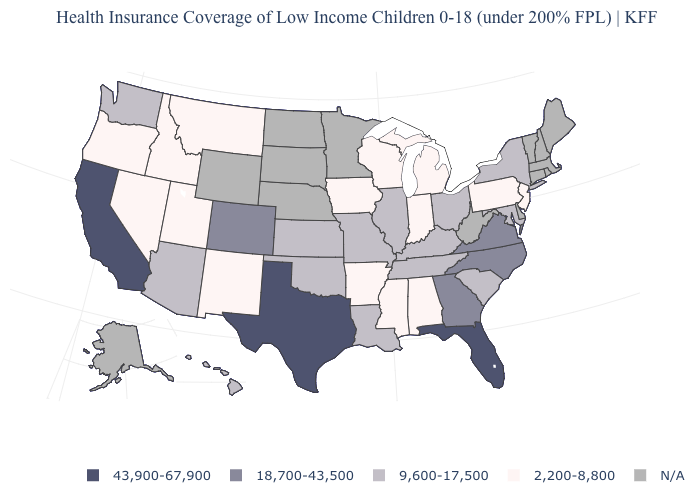Among the states that border New Jersey , which have the highest value?
Write a very short answer. New York. Does the first symbol in the legend represent the smallest category?
Keep it brief. No. How many symbols are there in the legend?
Give a very brief answer. 5. Name the states that have a value in the range 2,200-8,800?
Write a very short answer. Alabama, Arkansas, Idaho, Indiana, Iowa, Michigan, Mississippi, Montana, Nevada, New Jersey, New Mexico, Oregon, Pennsylvania, Utah, Wisconsin. Name the states that have a value in the range 9,600-17,500?
Quick response, please. Arizona, Hawaii, Illinois, Kansas, Kentucky, Louisiana, Maryland, Missouri, New York, Ohio, Oklahoma, South Carolina, Tennessee, Washington. Name the states that have a value in the range N/A?
Be succinct. Alaska, Connecticut, Delaware, Maine, Massachusetts, Minnesota, Nebraska, New Hampshire, North Dakota, Rhode Island, South Dakota, Vermont, West Virginia, Wyoming. Name the states that have a value in the range 2,200-8,800?
Write a very short answer. Alabama, Arkansas, Idaho, Indiana, Iowa, Michigan, Mississippi, Montana, Nevada, New Jersey, New Mexico, Oregon, Pennsylvania, Utah, Wisconsin. What is the value of Mississippi?
Be succinct. 2,200-8,800. Name the states that have a value in the range 18,700-43,500?
Give a very brief answer. Colorado, Georgia, North Carolina, Virginia. Name the states that have a value in the range 2,200-8,800?
Keep it brief. Alabama, Arkansas, Idaho, Indiana, Iowa, Michigan, Mississippi, Montana, Nevada, New Jersey, New Mexico, Oregon, Pennsylvania, Utah, Wisconsin. Which states have the lowest value in the USA?
Quick response, please. Alabama, Arkansas, Idaho, Indiana, Iowa, Michigan, Mississippi, Montana, Nevada, New Jersey, New Mexico, Oregon, Pennsylvania, Utah, Wisconsin. Name the states that have a value in the range 43,900-67,900?
Be succinct. California, Florida, Texas. Does the first symbol in the legend represent the smallest category?
Concise answer only. No. Does the first symbol in the legend represent the smallest category?
Be succinct. No. 